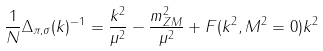<formula> <loc_0><loc_0><loc_500><loc_500>\frac { 1 } { N } \Delta _ { \pi , \sigma } ( k ) ^ { - 1 } = \frac { k ^ { 2 } } { \mu ^ { 2 } } - \frac { m _ { Z M } ^ { 2 } } { \mu ^ { 2 } } + F ( k ^ { 2 } , M ^ { 2 } = 0 ) k ^ { 2 }</formula> 